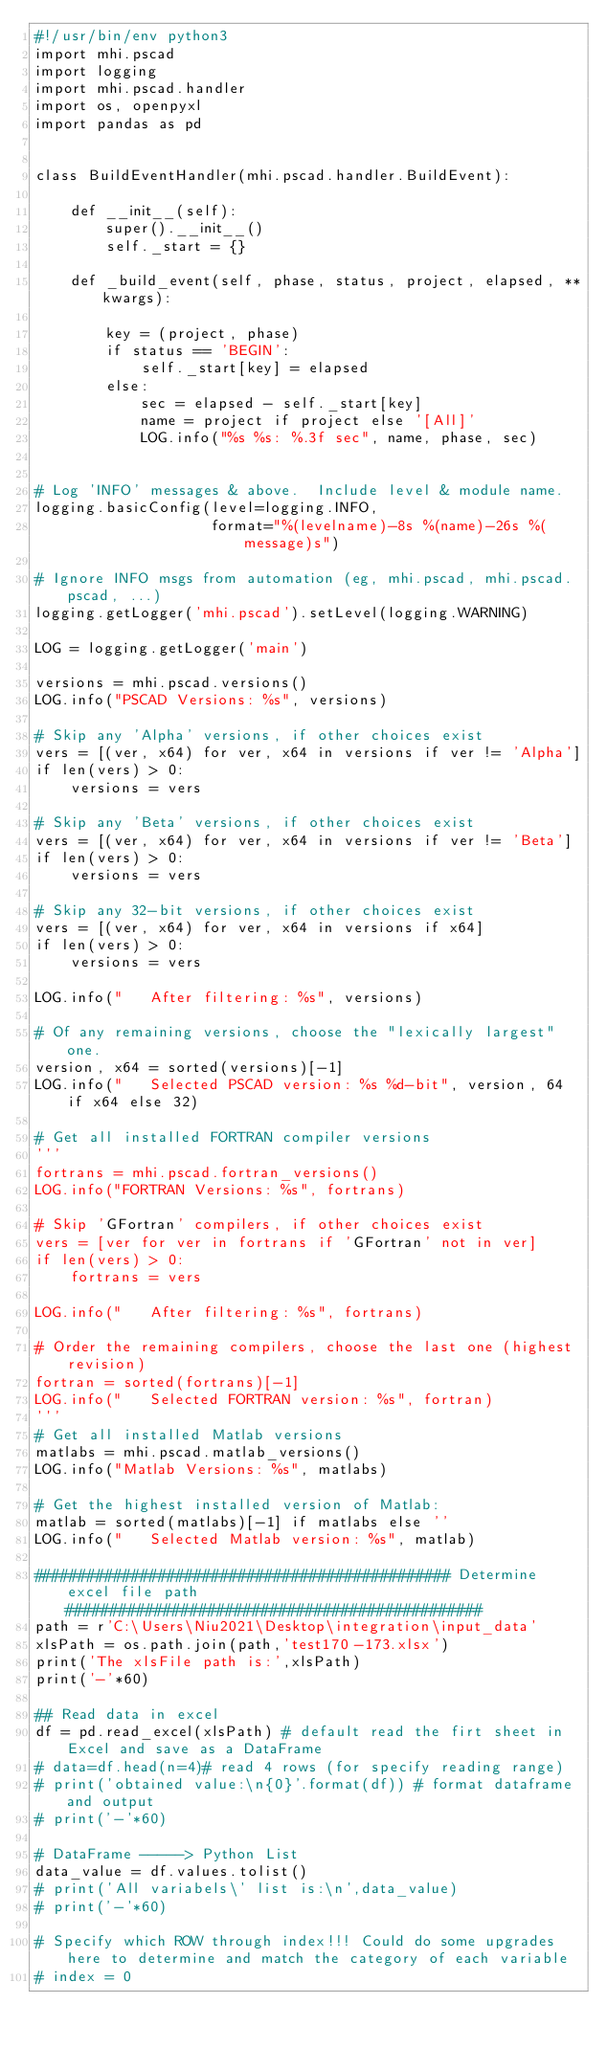<code> <loc_0><loc_0><loc_500><loc_500><_Python_>#!/usr/bin/env python3
import mhi.pscad
import logging
import mhi.pscad.handler
import os, openpyxl
import pandas as pd


class BuildEventHandler(mhi.pscad.handler.BuildEvent):

    def __init__(self):
        super().__init__()
        self._start = {}

    def _build_event(self, phase, status, project, elapsed, **kwargs):

        key = (project, phase)
        if status == 'BEGIN':
            self._start[key] = elapsed
        else:
            sec = elapsed - self._start[key]
            name = project if project else '[All]'
            LOG.info("%s %s: %.3f sec", name, phase, sec)


# Log 'INFO' messages & above.  Include level & module name.
logging.basicConfig(level=logging.INFO,
                    format="%(levelname)-8s %(name)-26s %(message)s")

# Ignore INFO msgs from automation (eg, mhi.pscad, mhi.pscad.pscad, ...)
logging.getLogger('mhi.pscad').setLevel(logging.WARNING)

LOG = logging.getLogger('main')

versions = mhi.pscad.versions()
LOG.info("PSCAD Versions: %s", versions)

# Skip any 'Alpha' versions, if other choices exist
vers = [(ver, x64) for ver, x64 in versions if ver != 'Alpha']
if len(vers) > 0:
    versions = vers

# Skip any 'Beta' versions, if other choices exist
vers = [(ver, x64) for ver, x64 in versions if ver != 'Beta']
if len(vers) > 0:
    versions = vers

# Skip any 32-bit versions, if other choices exist
vers = [(ver, x64) for ver, x64 in versions if x64]
if len(vers) > 0:
    versions = vers

LOG.info("   After filtering: %s", versions)

# Of any remaining versions, choose the "lexically largest" one.
version, x64 = sorted(versions)[-1]
LOG.info("   Selected PSCAD version: %s %d-bit", version, 64 if x64 else 32)

# Get all installed FORTRAN compiler versions
'''
fortrans = mhi.pscad.fortran_versions()
LOG.info("FORTRAN Versions: %s", fortrans)

# Skip 'GFortran' compilers, if other choices exist
vers = [ver for ver in fortrans if 'GFortran' not in ver]
if len(vers) > 0:
    fortrans = vers

LOG.info("   After filtering: %s", fortrans)

# Order the remaining compilers, choose the last one (highest revision)
fortran = sorted(fortrans)[-1]
LOG.info("   Selected FORTRAN version: %s", fortran)
'''
# Get all installed Matlab versions
matlabs = mhi.pscad.matlab_versions()
LOG.info("Matlab Versions: %s", matlabs)

# Get the highest installed version of Matlab:
matlab = sorted(matlabs)[-1] if matlabs else ''
LOG.info("   Selected Matlab version: %s", matlab)

############################################### Determine excel file path ###############################################
path = r'C:\Users\Niu2021\Desktop\integration\input_data'
xlsPath = os.path.join(path,'test170-173.xlsx')
print('The xlsFile path is:',xlsPath)
print('-'*60)

## Read data in excel
df = pd.read_excel(xlsPath) # default read the firt sheet in Excel and save as a DataFrame
# data=df.head(n=4)# read 4 rows (for specify reading range)
# print('obtained value:\n{0}'.format(df)) # format dataframe and output
# print('-'*60)

# DataFrame -----> Python List
data_value = df.values.tolist()
# print('All variabels\' list is:\n',data_value)
# print('-'*60)

# Specify which ROW through index!!! Could do some upgrades here to determine and match the category of each variable
# index = 0</code> 